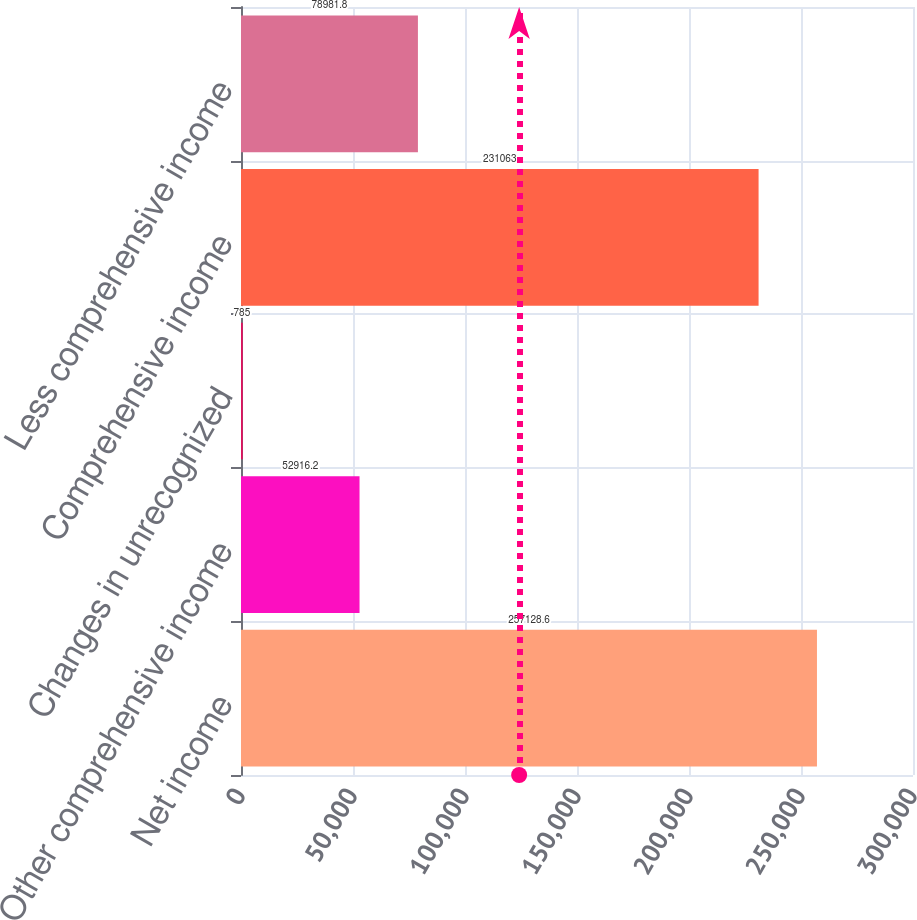<chart> <loc_0><loc_0><loc_500><loc_500><bar_chart><fcel>Net income<fcel>Other comprehensive income<fcel>Changes in unrecognized<fcel>Comprehensive income<fcel>Less comprehensive income<nl><fcel>257129<fcel>52916.2<fcel>785<fcel>231063<fcel>78981.8<nl></chart> 